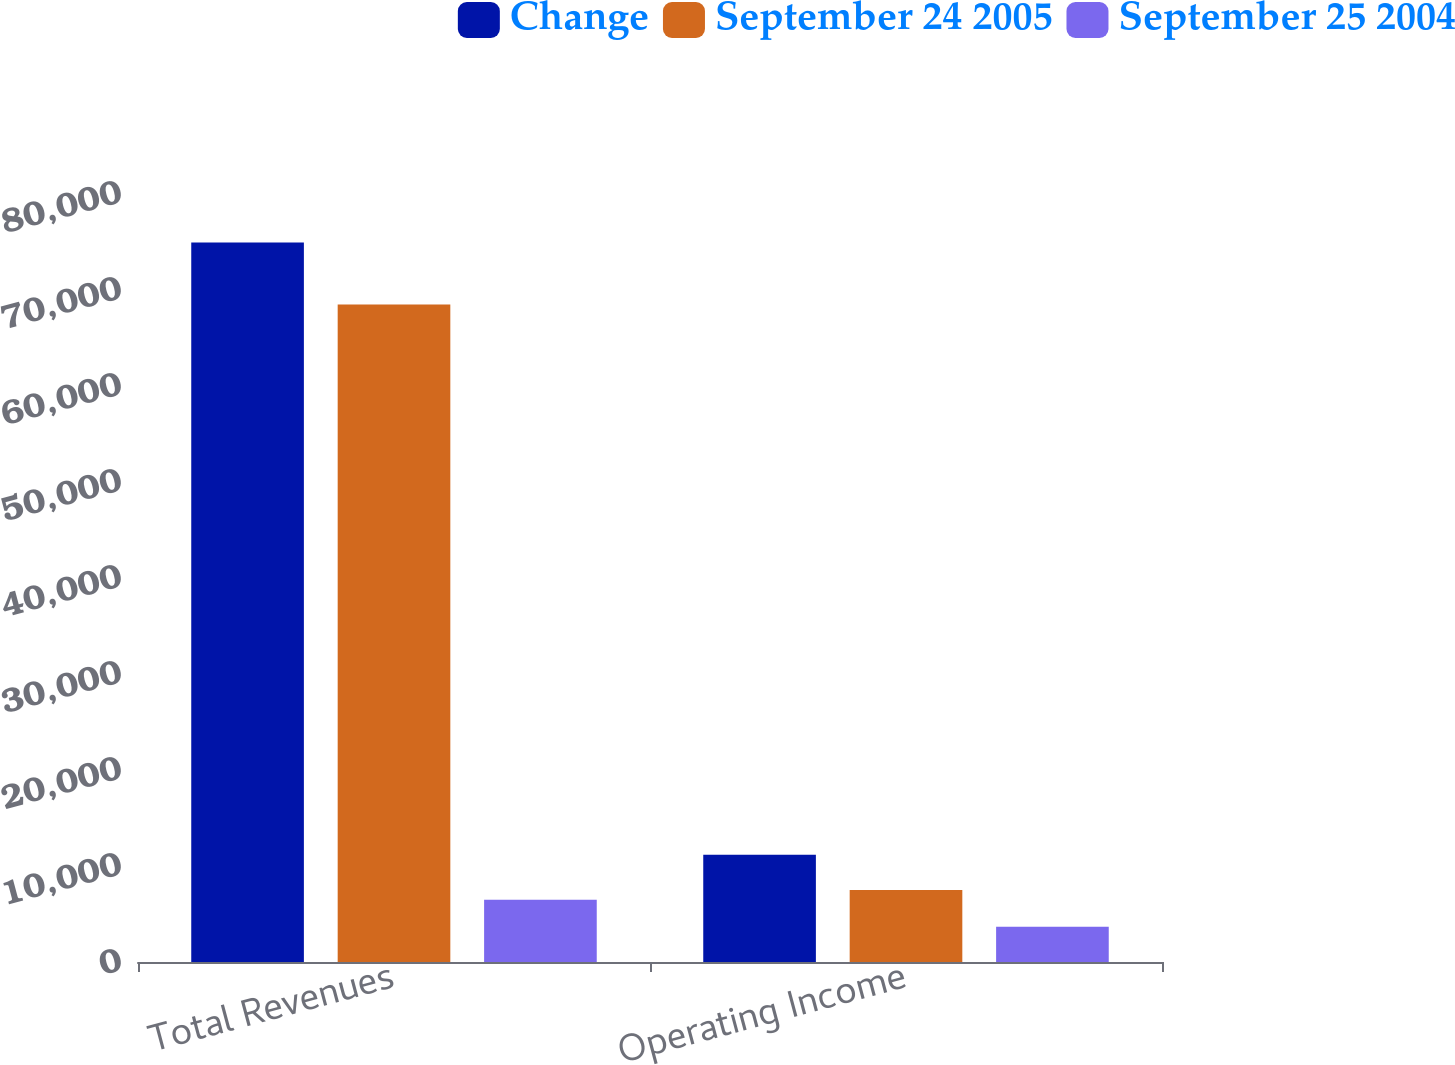Convert chart to OTSL. <chart><loc_0><loc_0><loc_500><loc_500><stacked_bar_chart><ecel><fcel>Total Revenues<fcel>Operating Income<nl><fcel>Change<fcel>74957<fcel>11175<nl><fcel>September 24 2005<fcel>68483<fcel>7500<nl><fcel>September 25 2004<fcel>6474<fcel>3675<nl></chart> 